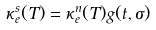Convert formula to latex. <formula><loc_0><loc_0><loc_500><loc_500>\kappa _ { e } ^ { s } ( T ) = \kappa _ { e } ^ { n } ( T ) g ( t , \sigma )</formula> 